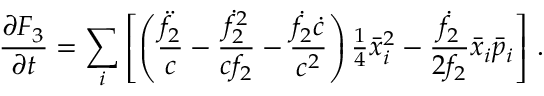<formula> <loc_0><loc_0><loc_500><loc_500>\frac { \partial F _ { 3 } } { \partial t } = \sum _ { i } \left [ \left ( \frac { \ddot { f } _ { 2 } } { c } - \frac { \dot { f } _ { 2 } ^ { 2 } } { c f _ { 2 } } - \frac { \dot { f } _ { 2 } \dot { c } } { c ^ { 2 } } \right ) { \frac { 1 } { 4 } } \bar { x } _ { i } ^ { 2 } - \frac { \dot { f } _ { 2 } } { 2 f _ { 2 } } \bar { x } _ { i } \bar { p } _ { i } \right ] \, .</formula> 